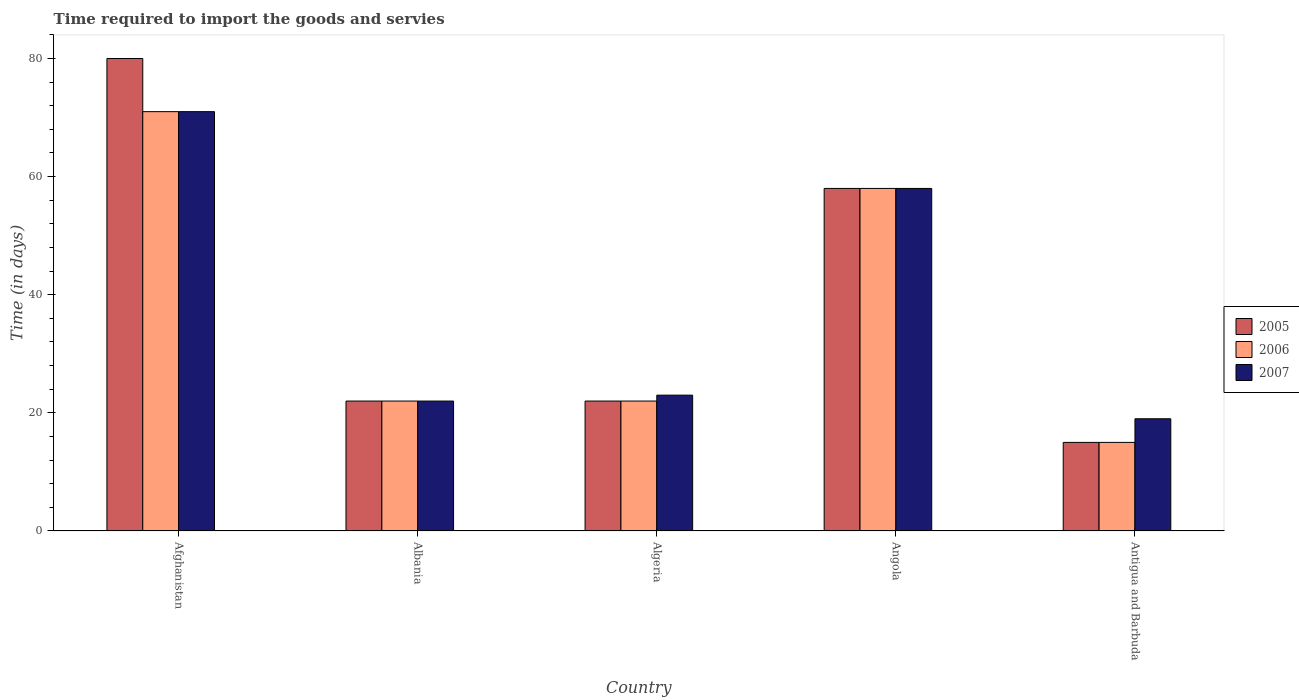How many different coloured bars are there?
Offer a terse response. 3. How many groups of bars are there?
Ensure brevity in your answer.  5. Are the number of bars per tick equal to the number of legend labels?
Give a very brief answer. Yes. Are the number of bars on each tick of the X-axis equal?
Keep it short and to the point. Yes. What is the label of the 5th group of bars from the left?
Offer a terse response. Antigua and Barbuda. In how many cases, is the number of bars for a given country not equal to the number of legend labels?
Make the answer very short. 0. In which country was the number of days required to import the goods and services in 2005 maximum?
Keep it short and to the point. Afghanistan. In which country was the number of days required to import the goods and services in 2007 minimum?
Ensure brevity in your answer.  Antigua and Barbuda. What is the total number of days required to import the goods and services in 2007 in the graph?
Your answer should be very brief. 193. What is the difference between the number of days required to import the goods and services in 2005 in Afghanistan and that in Angola?
Provide a succinct answer. 22. What is the difference between the number of days required to import the goods and services in 2006 in Antigua and Barbuda and the number of days required to import the goods and services in 2005 in Angola?
Offer a very short reply. -43. What is the average number of days required to import the goods and services in 2005 per country?
Your response must be concise. 39.4. What is the ratio of the number of days required to import the goods and services in 2005 in Albania to that in Angola?
Offer a terse response. 0.38. Is the number of days required to import the goods and services in 2007 in Afghanistan less than that in Angola?
Your response must be concise. No. What does the 2nd bar from the left in Afghanistan represents?
Keep it short and to the point. 2006. Are all the bars in the graph horizontal?
Offer a terse response. No. What is the difference between two consecutive major ticks on the Y-axis?
Give a very brief answer. 20. Does the graph contain grids?
Offer a terse response. No. What is the title of the graph?
Offer a very short reply. Time required to import the goods and servies. What is the label or title of the X-axis?
Your answer should be compact. Country. What is the label or title of the Y-axis?
Provide a short and direct response. Time (in days). What is the Time (in days) in 2005 in Afghanistan?
Your answer should be compact. 80. What is the Time (in days) of 2006 in Afghanistan?
Your answer should be very brief. 71. What is the Time (in days) in 2005 in Albania?
Provide a short and direct response. 22. What is the Time (in days) of 2007 in Albania?
Keep it short and to the point. 22. What is the Time (in days) of 2007 in Algeria?
Your answer should be very brief. 23. What is the Time (in days) in 2005 in Angola?
Ensure brevity in your answer.  58. What is the Time (in days) of 2007 in Angola?
Offer a terse response. 58. Across all countries, what is the maximum Time (in days) in 2005?
Your response must be concise. 80. Across all countries, what is the maximum Time (in days) of 2006?
Your answer should be compact. 71. Across all countries, what is the maximum Time (in days) in 2007?
Your answer should be compact. 71. Across all countries, what is the minimum Time (in days) in 2006?
Your answer should be very brief. 15. What is the total Time (in days) in 2005 in the graph?
Ensure brevity in your answer.  197. What is the total Time (in days) in 2006 in the graph?
Make the answer very short. 188. What is the total Time (in days) of 2007 in the graph?
Your answer should be very brief. 193. What is the difference between the Time (in days) in 2006 in Afghanistan and that in Albania?
Give a very brief answer. 49. What is the difference between the Time (in days) in 2007 in Afghanistan and that in Albania?
Your response must be concise. 49. What is the difference between the Time (in days) of 2005 in Afghanistan and that in Algeria?
Offer a very short reply. 58. What is the difference between the Time (in days) of 2005 in Afghanistan and that in Angola?
Offer a very short reply. 22. What is the difference between the Time (in days) in 2007 in Afghanistan and that in Angola?
Ensure brevity in your answer.  13. What is the difference between the Time (in days) of 2005 in Afghanistan and that in Antigua and Barbuda?
Provide a succinct answer. 65. What is the difference between the Time (in days) of 2007 in Afghanistan and that in Antigua and Barbuda?
Give a very brief answer. 52. What is the difference between the Time (in days) in 2005 in Albania and that in Algeria?
Keep it short and to the point. 0. What is the difference between the Time (in days) of 2006 in Albania and that in Algeria?
Offer a very short reply. 0. What is the difference between the Time (in days) of 2007 in Albania and that in Algeria?
Offer a very short reply. -1. What is the difference between the Time (in days) in 2005 in Albania and that in Angola?
Keep it short and to the point. -36. What is the difference between the Time (in days) in 2006 in Albania and that in Angola?
Offer a very short reply. -36. What is the difference between the Time (in days) in 2007 in Albania and that in Angola?
Your response must be concise. -36. What is the difference between the Time (in days) of 2006 in Albania and that in Antigua and Barbuda?
Make the answer very short. 7. What is the difference between the Time (in days) in 2007 in Albania and that in Antigua and Barbuda?
Ensure brevity in your answer.  3. What is the difference between the Time (in days) in 2005 in Algeria and that in Angola?
Your response must be concise. -36. What is the difference between the Time (in days) in 2006 in Algeria and that in Angola?
Your answer should be very brief. -36. What is the difference between the Time (in days) in 2007 in Algeria and that in Angola?
Make the answer very short. -35. What is the difference between the Time (in days) in 2005 in Algeria and that in Antigua and Barbuda?
Your answer should be very brief. 7. What is the difference between the Time (in days) in 2007 in Algeria and that in Antigua and Barbuda?
Ensure brevity in your answer.  4. What is the difference between the Time (in days) of 2007 in Angola and that in Antigua and Barbuda?
Keep it short and to the point. 39. What is the difference between the Time (in days) in 2005 in Afghanistan and the Time (in days) in 2006 in Albania?
Ensure brevity in your answer.  58. What is the difference between the Time (in days) in 2005 in Afghanistan and the Time (in days) in 2007 in Albania?
Offer a very short reply. 58. What is the difference between the Time (in days) of 2006 in Afghanistan and the Time (in days) of 2007 in Albania?
Provide a short and direct response. 49. What is the difference between the Time (in days) of 2006 in Afghanistan and the Time (in days) of 2007 in Algeria?
Keep it short and to the point. 48. What is the difference between the Time (in days) in 2005 in Afghanistan and the Time (in days) in 2007 in Angola?
Offer a terse response. 22. What is the difference between the Time (in days) of 2006 in Afghanistan and the Time (in days) of 2007 in Angola?
Your answer should be compact. 13. What is the difference between the Time (in days) of 2005 in Afghanistan and the Time (in days) of 2006 in Antigua and Barbuda?
Your answer should be compact. 65. What is the difference between the Time (in days) in 2005 in Albania and the Time (in days) in 2007 in Algeria?
Provide a short and direct response. -1. What is the difference between the Time (in days) in 2005 in Albania and the Time (in days) in 2006 in Angola?
Offer a very short reply. -36. What is the difference between the Time (in days) in 2005 in Albania and the Time (in days) in 2007 in Angola?
Provide a succinct answer. -36. What is the difference between the Time (in days) of 2006 in Albania and the Time (in days) of 2007 in Angola?
Your answer should be very brief. -36. What is the difference between the Time (in days) of 2005 in Albania and the Time (in days) of 2006 in Antigua and Barbuda?
Your answer should be very brief. 7. What is the difference between the Time (in days) in 2005 in Albania and the Time (in days) in 2007 in Antigua and Barbuda?
Offer a terse response. 3. What is the difference between the Time (in days) in 2005 in Algeria and the Time (in days) in 2006 in Angola?
Provide a succinct answer. -36. What is the difference between the Time (in days) of 2005 in Algeria and the Time (in days) of 2007 in Angola?
Your answer should be very brief. -36. What is the difference between the Time (in days) of 2006 in Algeria and the Time (in days) of 2007 in Angola?
Give a very brief answer. -36. What is the difference between the Time (in days) of 2005 in Algeria and the Time (in days) of 2006 in Antigua and Barbuda?
Offer a very short reply. 7. What is the difference between the Time (in days) in 2005 in Algeria and the Time (in days) in 2007 in Antigua and Barbuda?
Your response must be concise. 3. What is the difference between the Time (in days) in 2006 in Algeria and the Time (in days) in 2007 in Antigua and Barbuda?
Provide a short and direct response. 3. What is the difference between the Time (in days) in 2005 in Angola and the Time (in days) in 2007 in Antigua and Barbuda?
Give a very brief answer. 39. What is the difference between the Time (in days) in 2006 in Angola and the Time (in days) in 2007 in Antigua and Barbuda?
Your answer should be compact. 39. What is the average Time (in days) in 2005 per country?
Give a very brief answer. 39.4. What is the average Time (in days) of 2006 per country?
Your response must be concise. 37.6. What is the average Time (in days) in 2007 per country?
Ensure brevity in your answer.  38.6. What is the difference between the Time (in days) in 2005 and Time (in days) in 2006 in Afghanistan?
Ensure brevity in your answer.  9. What is the difference between the Time (in days) in 2005 and Time (in days) in 2007 in Afghanistan?
Make the answer very short. 9. What is the difference between the Time (in days) of 2006 and Time (in days) of 2007 in Afghanistan?
Ensure brevity in your answer.  0. What is the difference between the Time (in days) in 2005 and Time (in days) in 2006 in Albania?
Ensure brevity in your answer.  0. What is the difference between the Time (in days) in 2005 and Time (in days) in 2007 in Albania?
Provide a short and direct response. 0. What is the difference between the Time (in days) of 2005 and Time (in days) of 2007 in Algeria?
Your response must be concise. -1. What is the difference between the Time (in days) in 2006 and Time (in days) in 2007 in Algeria?
Keep it short and to the point. -1. What is the difference between the Time (in days) in 2005 and Time (in days) in 2006 in Angola?
Your answer should be compact. 0. What is the difference between the Time (in days) in 2005 and Time (in days) in 2007 in Angola?
Make the answer very short. 0. What is the difference between the Time (in days) of 2005 and Time (in days) of 2006 in Antigua and Barbuda?
Your answer should be compact. 0. What is the difference between the Time (in days) in 2005 and Time (in days) in 2007 in Antigua and Barbuda?
Your answer should be compact. -4. What is the difference between the Time (in days) in 2006 and Time (in days) in 2007 in Antigua and Barbuda?
Ensure brevity in your answer.  -4. What is the ratio of the Time (in days) in 2005 in Afghanistan to that in Albania?
Your answer should be compact. 3.64. What is the ratio of the Time (in days) in 2006 in Afghanistan to that in Albania?
Provide a succinct answer. 3.23. What is the ratio of the Time (in days) in 2007 in Afghanistan to that in Albania?
Offer a very short reply. 3.23. What is the ratio of the Time (in days) of 2005 in Afghanistan to that in Algeria?
Ensure brevity in your answer.  3.64. What is the ratio of the Time (in days) of 2006 in Afghanistan to that in Algeria?
Provide a succinct answer. 3.23. What is the ratio of the Time (in days) in 2007 in Afghanistan to that in Algeria?
Your answer should be compact. 3.09. What is the ratio of the Time (in days) in 2005 in Afghanistan to that in Angola?
Provide a succinct answer. 1.38. What is the ratio of the Time (in days) of 2006 in Afghanistan to that in Angola?
Give a very brief answer. 1.22. What is the ratio of the Time (in days) in 2007 in Afghanistan to that in Angola?
Ensure brevity in your answer.  1.22. What is the ratio of the Time (in days) in 2005 in Afghanistan to that in Antigua and Barbuda?
Offer a terse response. 5.33. What is the ratio of the Time (in days) in 2006 in Afghanistan to that in Antigua and Barbuda?
Make the answer very short. 4.73. What is the ratio of the Time (in days) of 2007 in Afghanistan to that in Antigua and Barbuda?
Your answer should be compact. 3.74. What is the ratio of the Time (in days) of 2005 in Albania to that in Algeria?
Your answer should be very brief. 1. What is the ratio of the Time (in days) in 2006 in Albania to that in Algeria?
Offer a very short reply. 1. What is the ratio of the Time (in days) in 2007 in Albania to that in Algeria?
Provide a short and direct response. 0.96. What is the ratio of the Time (in days) of 2005 in Albania to that in Angola?
Provide a short and direct response. 0.38. What is the ratio of the Time (in days) in 2006 in Albania to that in Angola?
Make the answer very short. 0.38. What is the ratio of the Time (in days) of 2007 in Albania to that in Angola?
Provide a short and direct response. 0.38. What is the ratio of the Time (in days) of 2005 in Albania to that in Antigua and Barbuda?
Offer a very short reply. 1.47. What is the ratio of the Time (in days) of 2006 in Albania to that in Antigua and Barbuda?
Offer a terse response. 1.47. What is the ratio of the Time (in days) in 2007 in Albania to that in Antigua and Barbuda?
Your answer should be very brief. 1.16. What is the ratio of the Time (in days) in 2005 in Algeria to that in Angola?
Your response must be concise. 0.38. What is the ratio of the Time (in days) in 2006 in Algeria to that in Angola?
Make the answer very short. 0.38. What is the ratio of the Time (in days) of 2007 in Algeria to that in Angola?
Make the answer very short. 0.4. What is the ratio of the Time (in days) of 2005 in Algeria to that in Antigua and Barbuda?
Make the answer very short. 1.47. What is the ratio of the Time (in days) in 2006 in Algeria to that in Antigua and Barbuda?
Your response must be concise. 1.47. What is the ratio of the Time (in days) of 2007 in Algeria to that in Antigua and Barbuda?
Make the answer very short. 1.21. What is the ratio of the Time (in days) of 2005 in Angola to that in Antigua and Barbuda?
Your response must be concise. 3.87. What is the ratio of the Time (in days) in 2006 in Angola to that in Antigua and Barbuda?
Ensure brevity in your answer.  3.87. What is the ratio of the Time (in days) in 2007 in Angola to that in Antigua and Barbuda?
Provide a short and direct response. 3.05. What is the difference between the highest and the second highest Time (in days) in 2005?
Give a very brief answer. 22. What is the difference between the highest and the second highest Time (in days) in 2006?
Keep it short and to the point. 13. What is the difference between the highest and the lowest Time (in days) of 2006?
Keep it short and to the point. 56. 